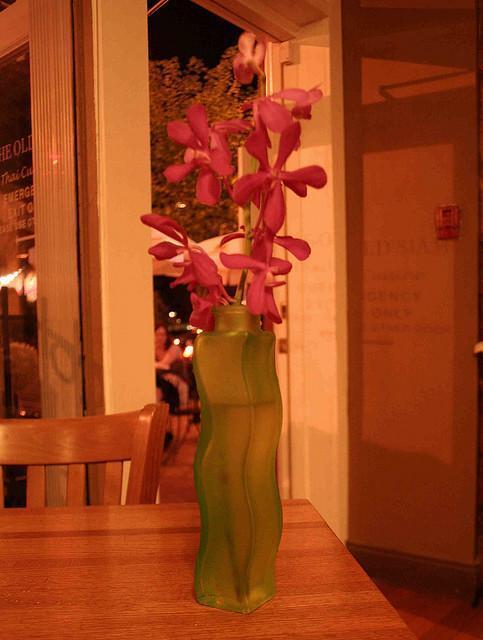How many chairs are at the table?
Give a very brief answer. 1. How many stems are in the vase?
Give a very brief answer. 2. How many dining tables can be seen?
Give a very brief answer. 2. How many chairs are there?
Give a very brief answer. 2. How many birds are in the picture?
Give a very brief answer. 0. 